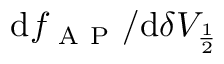<formula> <loc_0><loc_0><loc_500><loc_500>d f _ { A P } / d \delta V _ { \frac { 1 } { 2 } }</formula> 